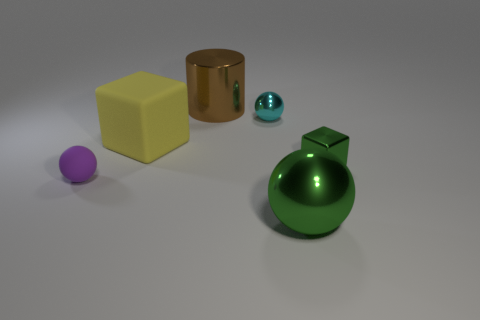Add 2 tiny cyan matte cubes. How many objects exist? 8 Subtract all cubes. How many objects are left? 4 Add 6 cyan metal cylinders. How many cyan metal cylinders exist? 6 Subtract 0 gray cylinders. How many objects are left? 6 Subtract all big rubber things. Subtract all metallic things. How many objects are left? 1 Add 5 small purple balls. How many small purple balls are left? 6 